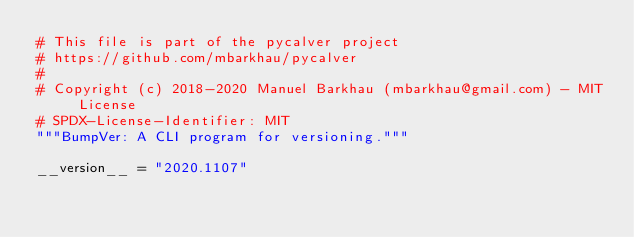Convert code to text. <code><loc_0><loc_0><loc_500><loc_500><_Python_># This file is part of the pycalver project
# https://github.com/mbarkhau/pycalver
#
# Copyright (c) 2018-2020 Manuel Barkhau (mbarkhau@gmail.com) - MIT License
# SPDX-License-Identifier: MIT
"""BumpVer: A CLI program for versioning."""

__version__ = "2020.1107"
</code> 